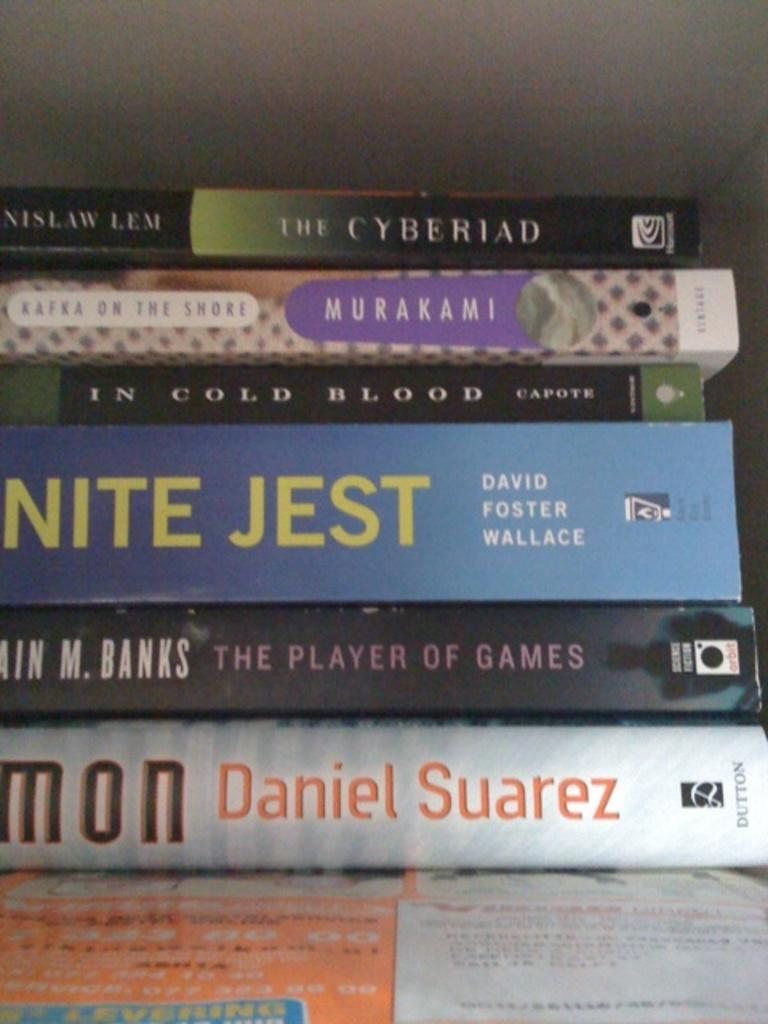Provide a one-sentence caption for the provided image. A stack of books contains a work by David Foster Wallace. 